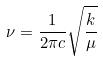Convert formula to latex. <formula><loc_0><loc_0><loc_500><loc_500>\nu = \frac { 1 } { 2 \pi c } \sqrt { \frac { k } { \mu } }</formula> 